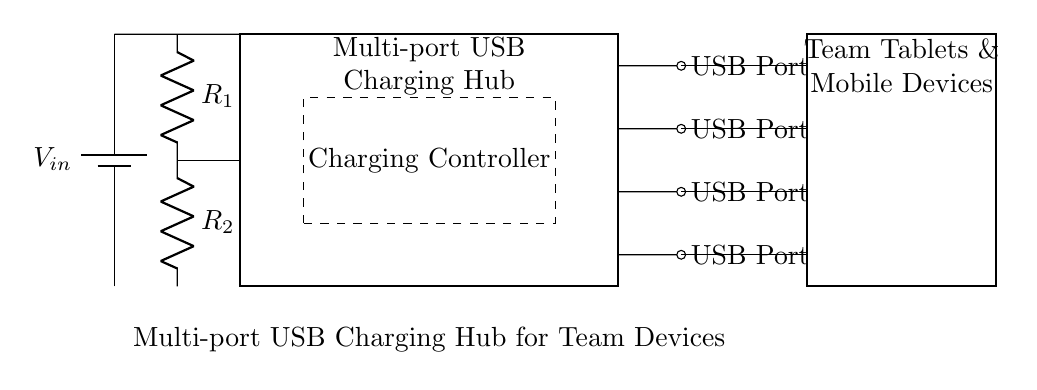What is the input voltage for the charging hub? The input voltage is labeled as V_in in the circuit diagram, indicating the external power supply voltage that will be used to power the hub.
Answer: V_in How many USB ports are there in the hub? The diagram shows four USB ports, each labeled specifically on the right side of the USB hub box.
Answer: 4 What component regulates the voltage in the circuit? The resistors R1 and R2 are mentioned in the circuit diagram, which can create an effective voltage regulation circuit depending on how they are configured.
Answer: R1 and R2 What is the function of the dashed rectangle in the diagram? The dashed rectangle represents the charging controller, which is responsible for managing how the devices connected to the USB ports receive power from the hub.
Answer: Charging Controller How are the team devices connected to the USB hub? The connection from each USB port to the team devices is illustrated by a solid line, indicating direct electrical connections from the hub to each device.
Answer: Direct connections If V_in is 5 volts, what is the expected output voltage for the devices? Assuming the charging mechanism in the hub is designed for standard USB outputs, the output voltage for charging devices is likely maintained at 5 volts or regulated appropriately based on the controller.
Answer: 5 volts What type of devices can be connected to the USB ports? The diagram indicates that the connected devices include team tablets and mobile devices, which are commonly charged through USB ports.
Answer: Team Tablets & Mobile Devices 